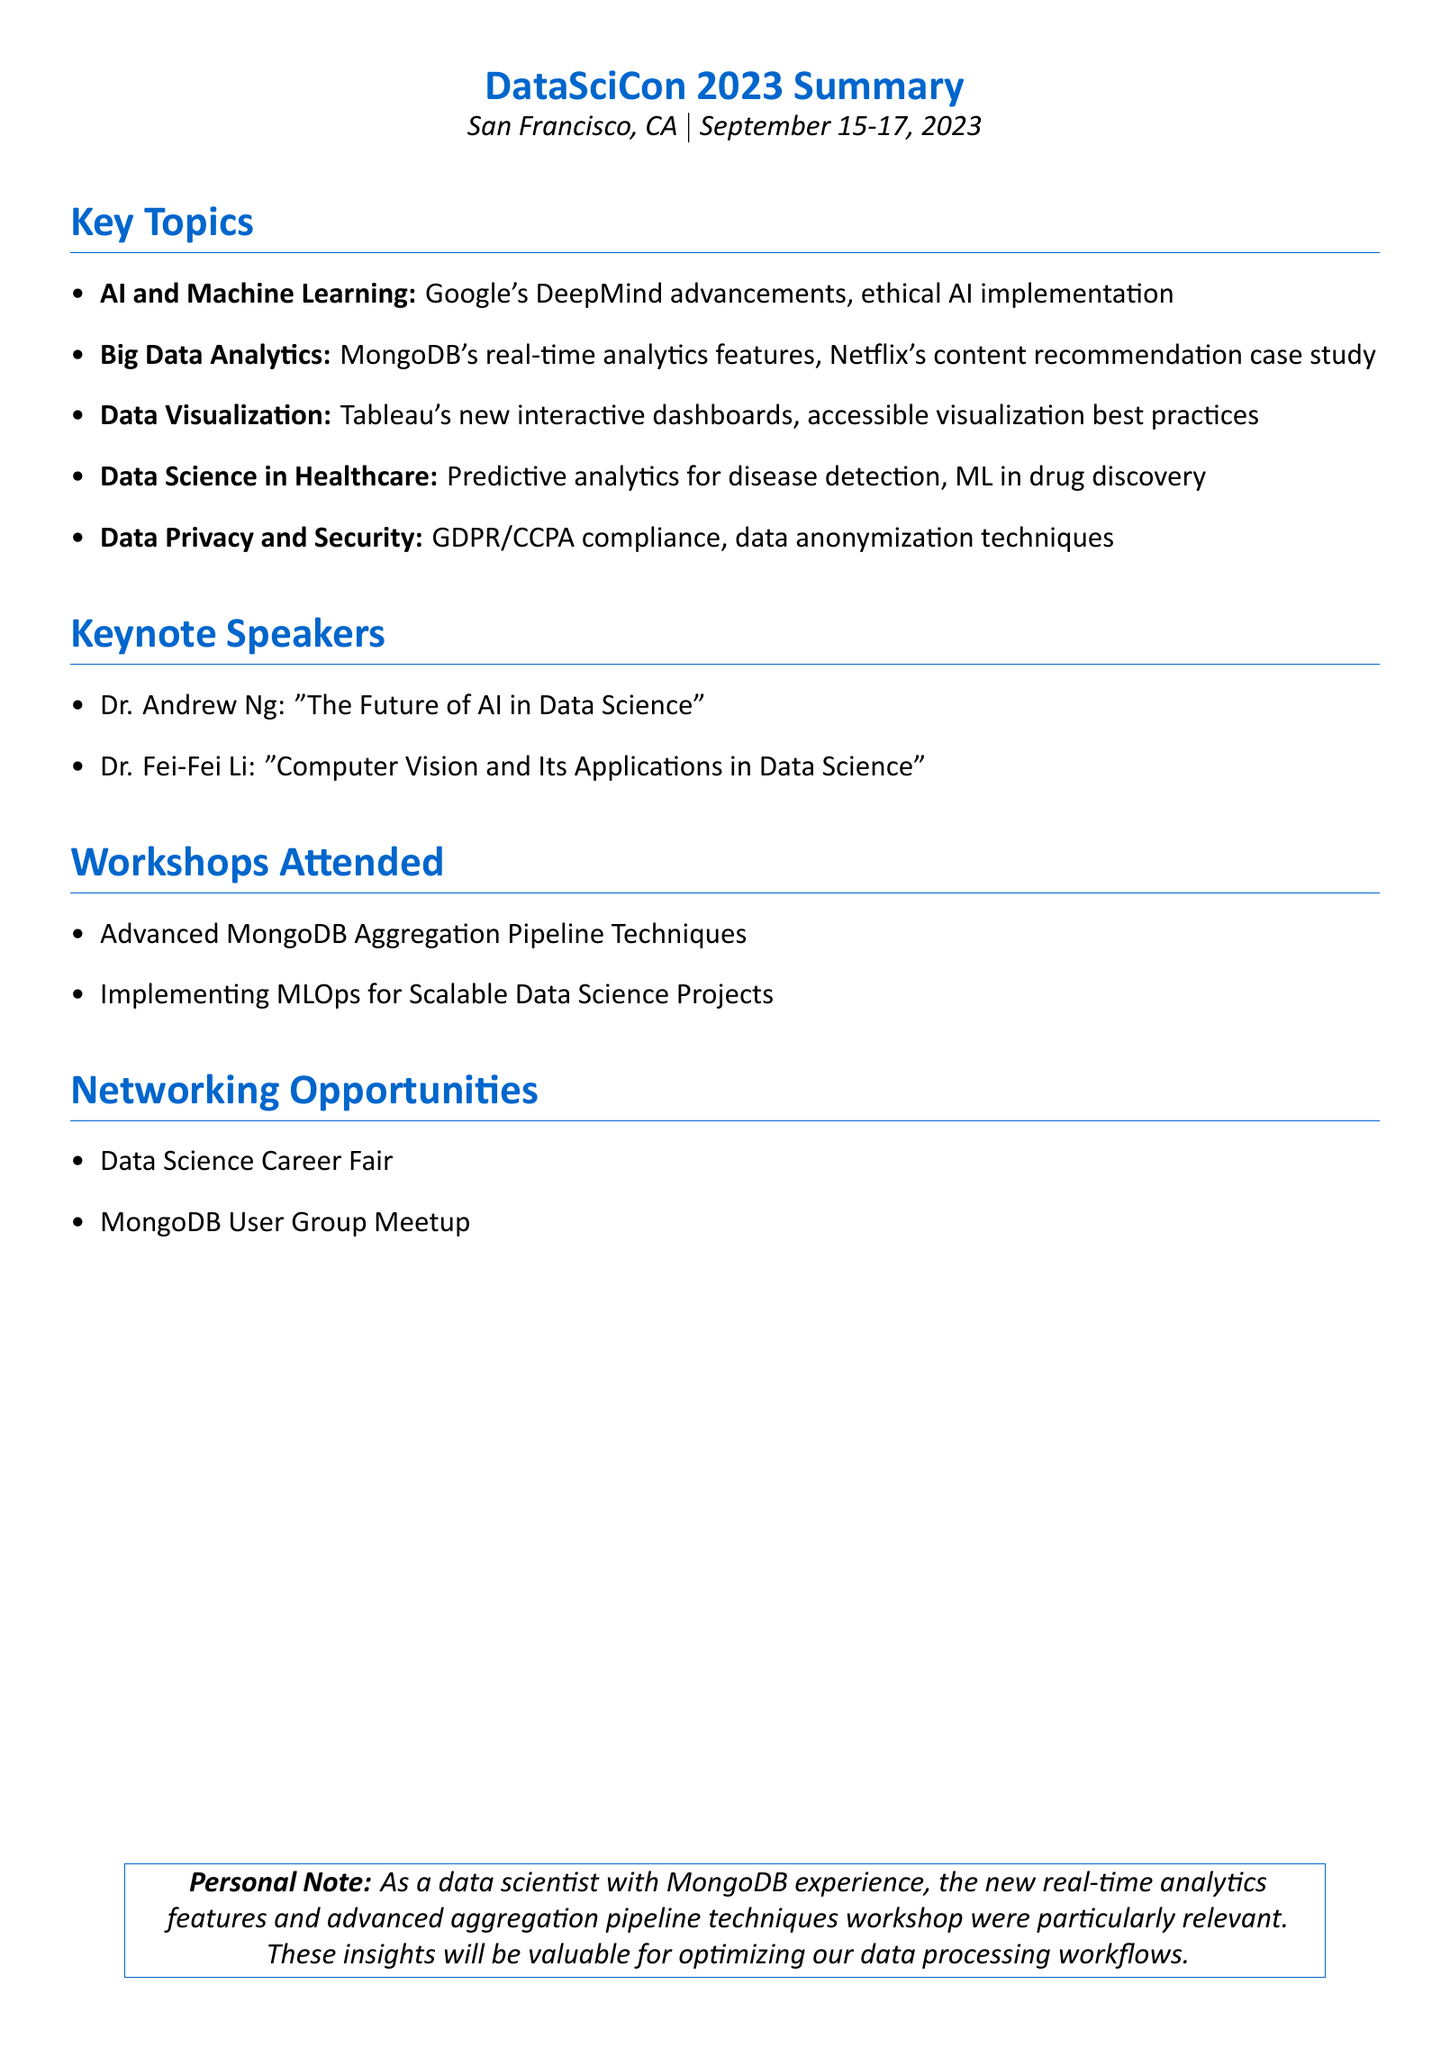What is the name of the conference? The document mentions the name of the conference as "DataSciCon 2023".
Answer: DataSciCon 2023 Where was the conference held? The conference location stated in the document is "San Francisco, CA".
Answer: San Francisco, CA What were the dates of the conference? The document specifies the dates as "September 15-17, 2023".
Answer: September 15-17, 2023 Who was the keynote speaker discussing AI? Dr. Andrew Ng is mentioned as the keynote speaker on the topic of AI.
Answer: Dr. Andrew Ng What topic did Tableau showcase? The document highlights "new interactive dashboard features" as Tableau's focus.
Answer: New interactive dashboard features Which workshop focused on MongoDB? "Advanced MongoDB Aggregation Pipeline Techniques" is the workshop mentioned about MongoDB.
Answer: Advanced MongoDB Aggregation Pipeline Techniques What compliance strategies were discussed? The document refers to "GDPR and CCPA compliance strategies" in the context of data privacy.
Answer: GDPR and CCPA compliance strategies What case study was presented in Big Data Analytics? The document states that Netflix's use of big data for content recommendation was discussed as a case study.
Answer: Netflix's use of big data for content recommendation What session topic did Dr. Fei-Fei Li cover? Dr. Fei-Fei Li covered the topic "Computer Vision and Its Applications in Data Science".
Answer: Computer Vision and Its Applications in Data Science 